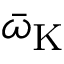<formula> <loc_0><loc_0><loc_500><loc_500>\bar { \omega } _ { K }</formula> 